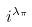<formula> <loc_0><loc_0><loc_500><loc_500>i ^ { \lambda _ { \pi } }</formula> 